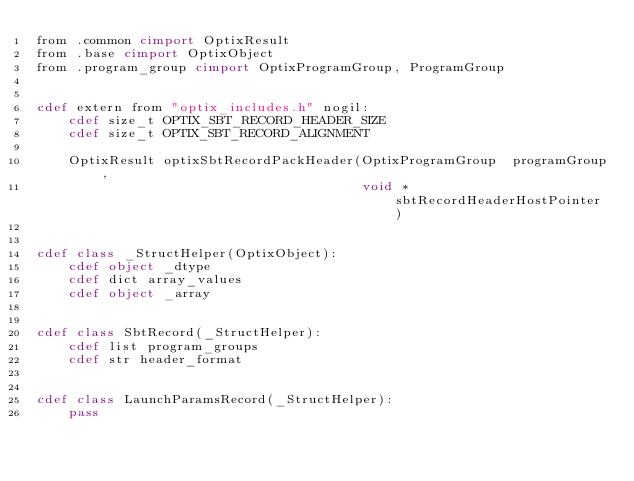<code> <loc_0><loc_0><loc_500><loc_500><_Cython_>from .common cimport OptixResult
from .base cimport OptixObject
from .program_group cimport OptixProgramGroup, ProgramGroup


cdef extern from "optix_includes.h" nogil:
    cdef size_t OPTIX_SBT_RECORD_HEADER_SIZE
    cdef size_t OPTIX_SBT_RECORD_ALIGNMENT

    OptixResult optixSbtRecordPackHeader(OptixProgramGroup 	programGroup,
                                         void * sbtRecordHeaderHostPointer)


cdef class _StructHelper(OptixObject):
    cdef object _dtype
    cdef dict array_values
    cdef object _array


cdef class SbtRecord(_StructHelper):
    cdef list program_groups
    cdef str header_format


cdef class LaunchParamsRecord(_StructHelper):
    pass
</code> 